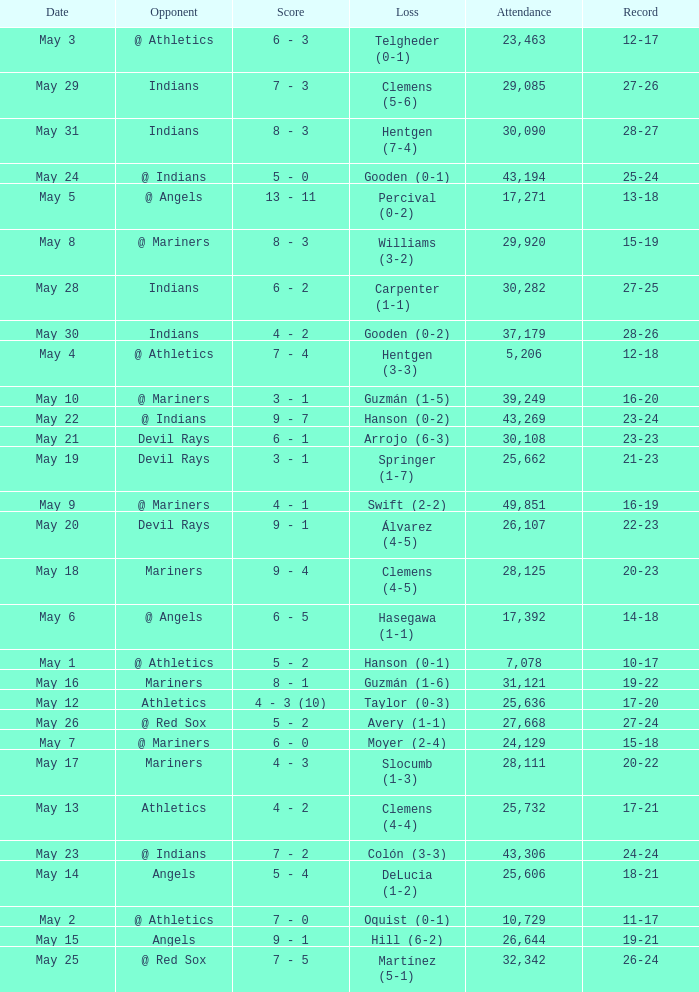Can you give me this table as a dict? {'header': ['Date', 'Opponent', 'Score', 'Loss', 'Attendance', 'Record'], 'rows': [['May 3', '@ Athletics', '6 - 3', 'Telgheder (0-1)', '23,463', '12-17'], ['May 29', 'Indians', '7 - 3', 'Clemens (5-6)', '29,085', '27-26'], ['May 31', 'Indians', '8 - 3', 'Hentgen (7-4)', '30,090', '28-27'], ['May 24', '@ Indians', '5 - 0', 'Gooden (0-1)', '43,194', '25-24'], ['May 5', '@ Angels', '13 - 11', 'Percival (0-2)', '17,271', '13-18'], ['May 8', '@ Mariners', '8 - 3', 'Williams (3-2)', '29,920', '15-19'], ['May 28', 'Indians', '6 - 2', 'Carpenter (1-1)', '30,282', '27-25'], ['May 30', 'Indians', '4 - 2', 'Gooden (0-2)', '37,179', '28-26'], ['May 4', '@ Athletics', '7 - 4', 'Hentgen (3-3)', '5,206', '12-18'], ['May 10', '@ Mariners', '3 - 1', 'Guzmán (1-5)', '39,249', '16-20'], ['May 22', '@ Indians', '9 - 7', 'Hanson (0-2)', '43,269', '23-24'], ['May 21', 'Devil Rays', '6 - 1', 'Arrojo (6-3)', '30,108', '23-23'], ['May 19', 'Devil Rays', '3 - 1', 'Springer (1-7)', '25,662', '21-23'], ['May 9', '@ Mariners', '4 - 1', 'Swift (2-2)', '49,851', '16-19'], ['May 20', 'Devil Rays', '9 - 1', 'Álvarez (4-5)', '26,107', '22-23'], ['May 18', 'Mariners', '9 - 4', 'Clemens (4-5)', '28,125', '20-23'], ['May 6', '@ Angels', '6 - 5', 'Hasegawa (1-1)', '17,392', '14-18'], ['May 1', '@ Athletics', '5 - 2', 'Hanson (0-1)', '7,078', '10-17'], ['May 16', 'Mariners', '8 - 1', 'Guzmán (1-6)', '31,121', '19-22'], ['May 12', 'Athletics', '4 - 3 (10)', 'Taylor (0-3)', '25,636', '17-20'], ['May 26', '@ Red Sox', '5 - 2', 'Avery (1-1)', '27,668', '27-24'], ['May 7', '@ Mariners', '6 - 0', 'Moyer (2-4)', '24,129', '15-18'], ['May 17', 'Mariners', '4 - 3', 'Slocumb (1-3)', '28,111', '20-22'], ['May 13', 'Athletics', '4 - 2', 'Clemens (4-4)', '25,732', '17-21'], ['May 23', '@ Indians', '7 - 2', 'Colón (3-3)', '43,306', '24-24'], ['May 14', 'Angels', '5 - 4', 'DeLucia (1-2)', '25,606', '18-21'], ['May 2', '@ Athletics', '7 - 0', 'Oquist (0-1)', '10,729', '11-17'], ['May 15', 'Angels', '9 - 1', 'Hill (6-2)', '26,644', '19-21'], ['May 25', '@ Red Sox', '7 - 5', 'Martínez (5-1)', '32,342', '26-24']]} When the record is 16-20 and attendance is greater than 32,342, what is the score? 3 - 1. 